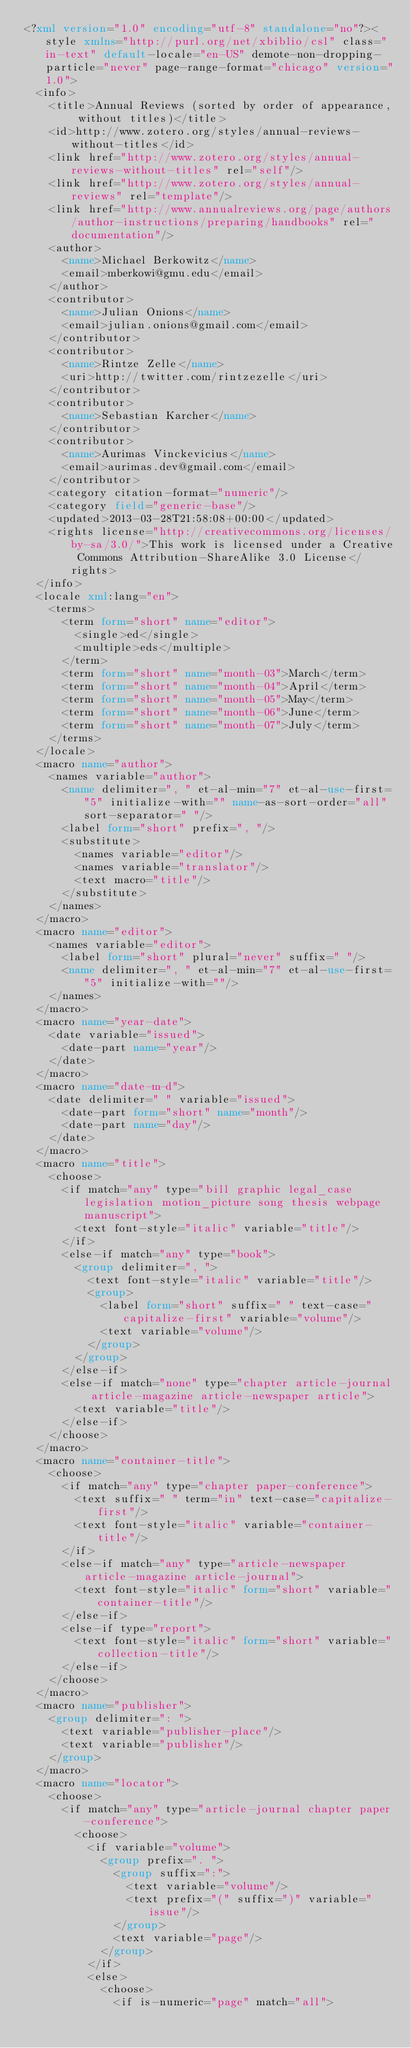Convert code to text. <code><loc_0><loc_0><loc_500><loc_500><_XML_><?xml version="1.0" encoding="utf-8" standalone="no"?><style xmlns="http://purl.org/net/xbiblio/csl" class="in-text" default-locale="en-US" demote-non-dropping-particle="never" page-range-format="chicago" version="1.0">
  <info>
    <title>Annual Reviews (sorted by order of appearance, without titles)</title>
    <id>http://www.zotero.org/styles/annual-reviews-without-titles</id>
    <link href="http://www.zotero.org/styles/annual-reviews-without-titles" rel="self"/>
    <link href="http://www.zotero.org/styles/annual-reviews" rel="template"/>
    <link href="http://www.annualreviews.org/page/authors/author-instructions/preparing/handbooks" rel="documentation"/>
    <author>
      <name>Michael Berkowitz</name>
      <email>mberkowi@gmu.edu</email>
    </author>
    <contributor>
      <name>Julian Onions</name>
      <email>julian.onions@gmail.com</email>
    </contributor>
    <contributor>
      <name>Rintze Zelle</name>
      <uri>http://twitter.com/rintzezelle</uri>
    </contributor>
    <contributor>
      <name>Sebastian Karcher</name>
    </contributor>
    <contributor>
      <name>Aurimas Vinckevicius</name>
      <email>aurimas.dev@gmail.com</email>
    </contributor>
    <category citation-format="numeric"/>
    <category field="generic-base"/>
    <updated>2013-03-28T21:58:08+00:00</updated>
    <rights license="http://creativecommons.org/licenses/by-sa/3.0/">This work is licensed under a Creative Commons Attribution-ShareAlike 3.0 License</rights>
  </info>
  <locale xml:lang="en">
    <terms>
      <term form="short" name="editor">
        <single>ed</single>
        <multiple>eds</multiple>
      </term>
      <term form="short" name="month-03">March</term>
      <term form="short" name="month-04">April</term>
      <term form="short" name="month-05">May</term>
      <term form="short" name="month-06">June</term>
      <term form="short" name="month-07">July</term>
    </terms>
  </locale>
  <macro name="author">
    <names variable="author">
      <name delimiter=", " et-al-min="7" et-al-use-first="5" initialize-with="" name-as-sort-order="all" sort-separator=" "/>
      <label form="short" prefix=", "/>
      <substitute>
        <names variable="editor"/>
        <names variable="translator"/>
        <text macro="title"/>
      </substitute>
    </names>
  </macro>
  <macro name="editor">
    <names variable="editor">
      <label form="short" plural="never" suffix=" "/>
      <name delimiter=", " et-al-min="7" et-al-use-first="5" initialize-with=""/>
    </names>
  </macro>
  <macro name="year-date">
    <date variable="issued">
      <date-part name="year"/>
    </date>
  </macro>
  <macro name="date-m-d">
    <date delimiter=" " variable="issued">
      <date-part form="short" name="month"/>
      <date-part name="day"/>
    </date>
  </macro>
  <macro name="title">
    <choose>
      <if match="any" type="bill graphic legal_case legislation motion_picture song thesis webpage manuscript">
        <text font-style="italic" variable="title"/>
      </if>
      <else-if match="any" type="book">
        <group delimiter=", ">
          <text font-style="italic" variable="title"/>
          <group>
            <label form="short" suffix=" " text-case="capitalize-first" variable="volume"/>
            <text variable="volume"/>
          </group>
        </group>
      </else-if>
      <else-if match="none" type="chapter article-journal article-magazine article-newspaper article">
        <text variable="title"/>
      </else-if>
    </choose>
  </macro>
  <macro name="container-title">
    <choose>
      <if match="any" type="chapter paper-conference">
        <text suffix=" " term="in" text-case="capitalize-first"/>
        <text font-style="italic" variable="container-title"/>
      </if>
      <else-if match="any" type="article-newspaper article-magazine article-journal">
        <text font-style="italic" form="short" variable="container-title"/>
      </else-if>
      <else-if type="report">
        <text font-style="italic" form="short" variable="collection-title"/>
      </else-if>
    </choose>
  </macro>
  <macro name="publisher">
    <group delimiter=": ">
      <text variable="publisher-place"/>
      <text variable="publisher"/>
    </group>
  </macro>
  <macro name="locator">
    <choose>
      <if match="any" type="article-journal chapter paper-conference">
        <choose>
          <if variable="volume">
            <group prefix=". ">
              <group suffix=":">
                <text variable="volume"/>
                <text prefix="(" suffix=")" variable="issue"/>
              </group>
              <text variable="page"/>
            </group>
          </if>
          <else>
            <choose>
              <if is-numeric="page" match="all"></code> 